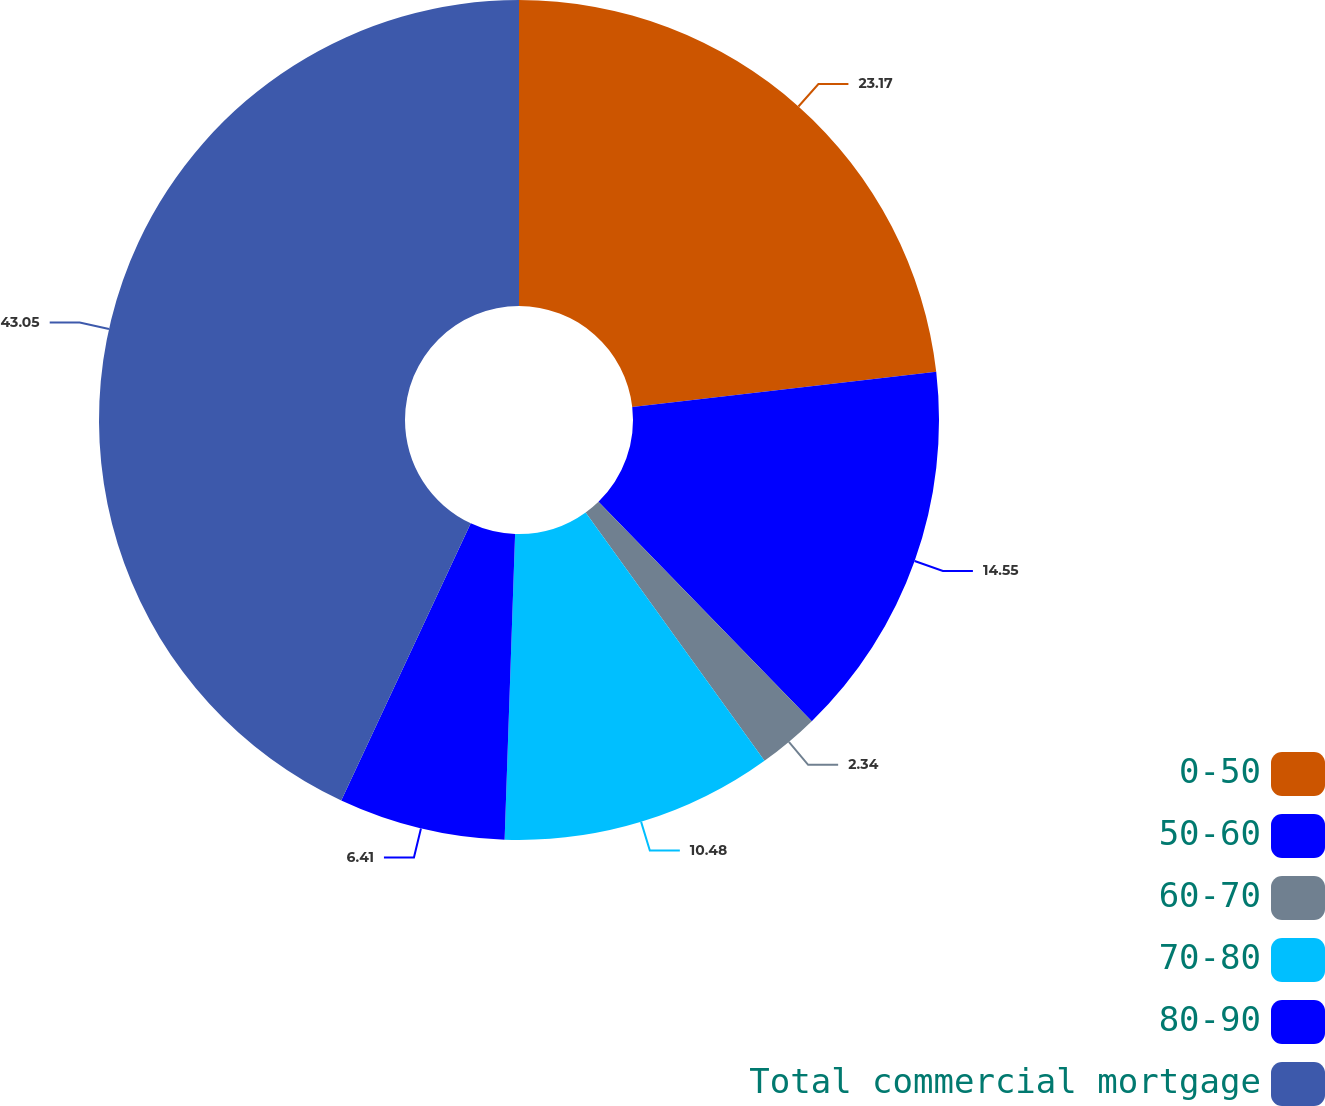Convert chart. <chart><loc_0><loc_0><loc_500><loc_500><pie_chart><fcel>0-50<fcel>50-60<fcel>60-70<fcel>70-80<fcel>80-90<fcel>Total commercial mortgage<nl><fcel>23.17%<fcel>14.55%<fcel>2.34%<fcel>10.48%<fcel>6.41%<fcel>43.04%<nl></chart> 